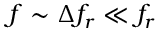<formula> <loc_0><loc_0><loc_500><loc_500>f \sim \Delta f _ { r } \ll f _ { r }</formula> 